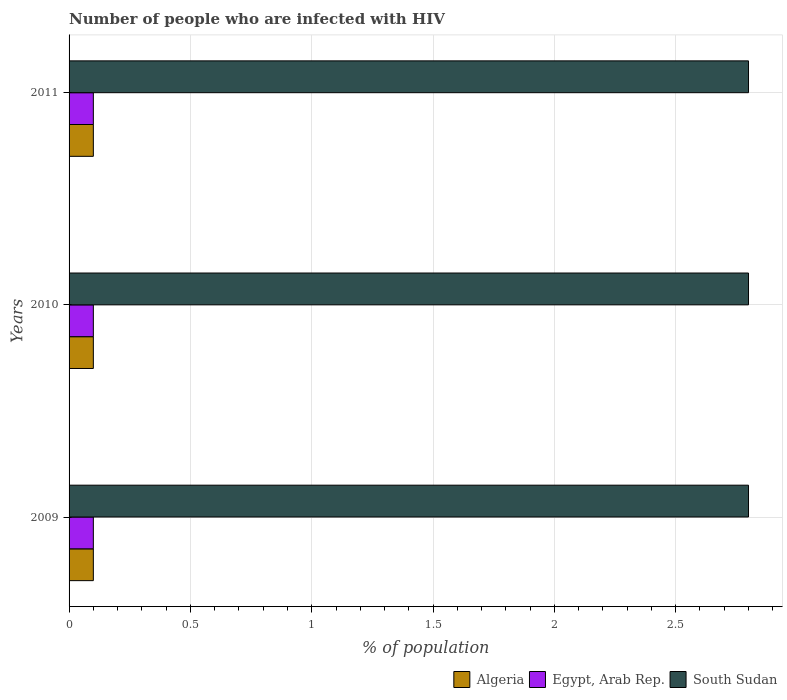How many different coloured bars are there?
Make the answer very short. 3. How many groups of bars are there?
Give a very brief answer. 3. Are the number of bars per tick equal to the number of legend labels?
Give a very brief answer. Yes. How many bars are there on the 3rd tick from the top?
Offer a terse response. 3. Across all years, what is the maximum percentage of HIV infected population in in South Sudan?
Provide a short and direct response. 2.8. Across all years, what is the minimum percentage of HIV infected population in in South Sudan?
Your response must be concise. 2.8. In which year was the percentage of HIV infected population in in Algeria maximum?
Keep it short and to the point. 2009. In which year was the percentage of HIV infected population in in Egypt, Arab Rep. minimum?
Offer a very short reply. 2009. What is the total percentage of HIV infected population in in South Sudan in the graph?
Your answer should be compact. 8.4. What is the difference between the percentage of HIV infected population in in Egypt, Arab Rep. in 2010 and the percentage of HIV infected population in in Algeria in 2011?
Your answer should be very brief. 0. What is the average percentage of HIV infected population in in South Sudan per year?
Offer a terse response. 2.8. In the year 2011, what is the difference between the percentage of HIV infected population in in Egypt, Arab Rep. and percentage of HIV infected population in in South Sudan?
Make the answer very short. -2.7. In how many years, is the percentage of HIV infected population in in South Sudan greater than 2.8 %?
Give a very brief answer. 0. What is the ratio of the percentage of HIV infected population in in South Sudan in 2010 to that in 2011?
Ensure brevity in your answer.  1. Is the percentage of HIV infected population in in Algeria in 2009 less than that in 2011?
Give a very brief answer. No. Is the sum of the percentage of HIV infected population in in Algeria in 2009 and 2010 greater than the maximum percentage of HIV infected population in in South Sudan across all years?
Your answer should be very brief. No. What does the 2nd bar from the top in 2010 represents?
Your response must be concise. Egypt, Arab Rep. What does the 2nd bar from the bottom in 2010 represents?
Provide a succinct answer. Egypt, Arab Rep. Is it the case that in every year, the sum of the percentage of HIV infected population in in South Sudan and percentage of HIV infected population in in Egypt, Arab Rep. is greater than the percentage of HIV infected population in in Algeria?
Give a very brief answer. Yes. Are all the bars in the graph horizontal?
Ensure brevity in your answer.  Yes. How many years are there in the graph?
Ensure brevity in your answer.  3. Are the values on the major ticks of X-axis written in scientific E-notation?
Your answer should be very brief. No. Does the graph contain any zero values?
Offer a terse response. No. Does the graph contain grids?
Offer a terse response. Yes. What is the title of the graph?
Provide a short and direct response. Number of people who are infected with HIV. What is the label or title of the X-axis?
Offer a very short reply. % of population. What is the label or title of the Y-axis?
Offer a terse response. Years. What is the % of population of Algeria in 2009?
Your answer should be compact. 0.1. What is the % of population of Egypt, Arab Rep. in 2009?
Give a very brief answer. 0.1. What is the % of population of South Sudan in 2009?
Make the answer very short. 2.8. What is the % of population in Algeria in 2010?
Offer a terse response. 0.1. What is the % of population in Egypt, Arab Rep. in 2010?
Give a very brief answer. 0.1. What is the % of population of South Sudan in 2010?
Offer a very short reply. 2.8. What is the % of population in Egypt, Arab Rep. in 2011?
Give a very brief answer. 0.1. What is the % of population of South Sudan in 2011?
Make the answer very short. 2.8. Across all years, what is the maximum % of population of Egypt, Arab Rep.?
Ensure brevity in your answer.  0.1. Across all years, what is the minimum % of population in Egypt, Arab Rep.?
Provide a succinct answer. 0.1. Across all years, what is the minimum % of population in South Sudan?
Offer a terse response. 2.8. What is the total % of population in Algeria in the graph?
Make the answer very short. 0.3. What is the total % of population in Egypt, Arab Rep. in the graph?
Keep it short and to the point. 0.3. What is the difference between the % of population in Algeria in 2009 and that in 2010?
Provide a succinct answer. 0. What is the difference between the % of population of South Sudan in 2009 and that in 2011?
Give a very brief answer. 0. What is the difference between the % of population of Algeria in 2009 and the % of population of South Sudan in 2011?
Make the answer very short. -2.7. What is the difference between the % of population of Algeria in 2010 and the % of population of South Sudan in 2011?
Give a very brief answer. -2.7. What is the average % of population of Egypt, Arab Rep. per year?
Offer a very short reply. 0.1. In the year 2009, what is the difference between the % of population in Algeria and % of population in Egypt, Arab Rep.?
Keep it short and to the point. 0. In the year 2009, what is the difference between the % of population of Algeria and % of population of South Sudan?
Your answer should be compact. -2.7. In the year 2009, what is the difference between the % of population in Egypt, Arab Rep. and % of population in South Sudan?
Keep it short and to the point. -2.7. In the year 2010, what is the difference between the % of population in Algeria and % of population in Egypt, Arab Rep.?
Your response must be concise. 0. In the year 2010, what is the difference between the % of population in Algeria and % of population in South Sudan?
Offer a very short reply. -2.7. In the year 2010, what is the difference between the % of population of Egypt, Arab Rep. and % of population of South Sudan?
Your answer should be compact. -2.7. In the year 2011, what is the difference between the % of population in Algeria and % of population in South Sudan?
Give a very brief answer. -2.7. In the year 2011, what is the difference between the % of population of Egypt, Arab Rep. and % of population of South Sudan?
Provide a short and direct response. -2.7. What is the ratio of the % of population in Algeria in 2009 to that in 2010?
Provide a succinct answer. 1. What is the ratio of the % of population in South Sudan in 2009 to that in 2010?
Give a very brief answer. 1. What is the ratio of the % of population in Algeria in 2010 to that in 2011?
Provide a succinct answer. 1. What is the ratio of the % of population of Egypt, Arab Rep. in 2010 to that in 2011?
Give a very brief answer. 1. What is the ratio of the % of population of South Sudan in 2010 to that in 2011?
Your response must be concise. 1. What is the difference between the highest and the second highest % of population in Algeria?
Keep it short and to the point. 0. What is the difference between the highest and the second highest % of population in South Sudan?
Offer a terse response. 0. 